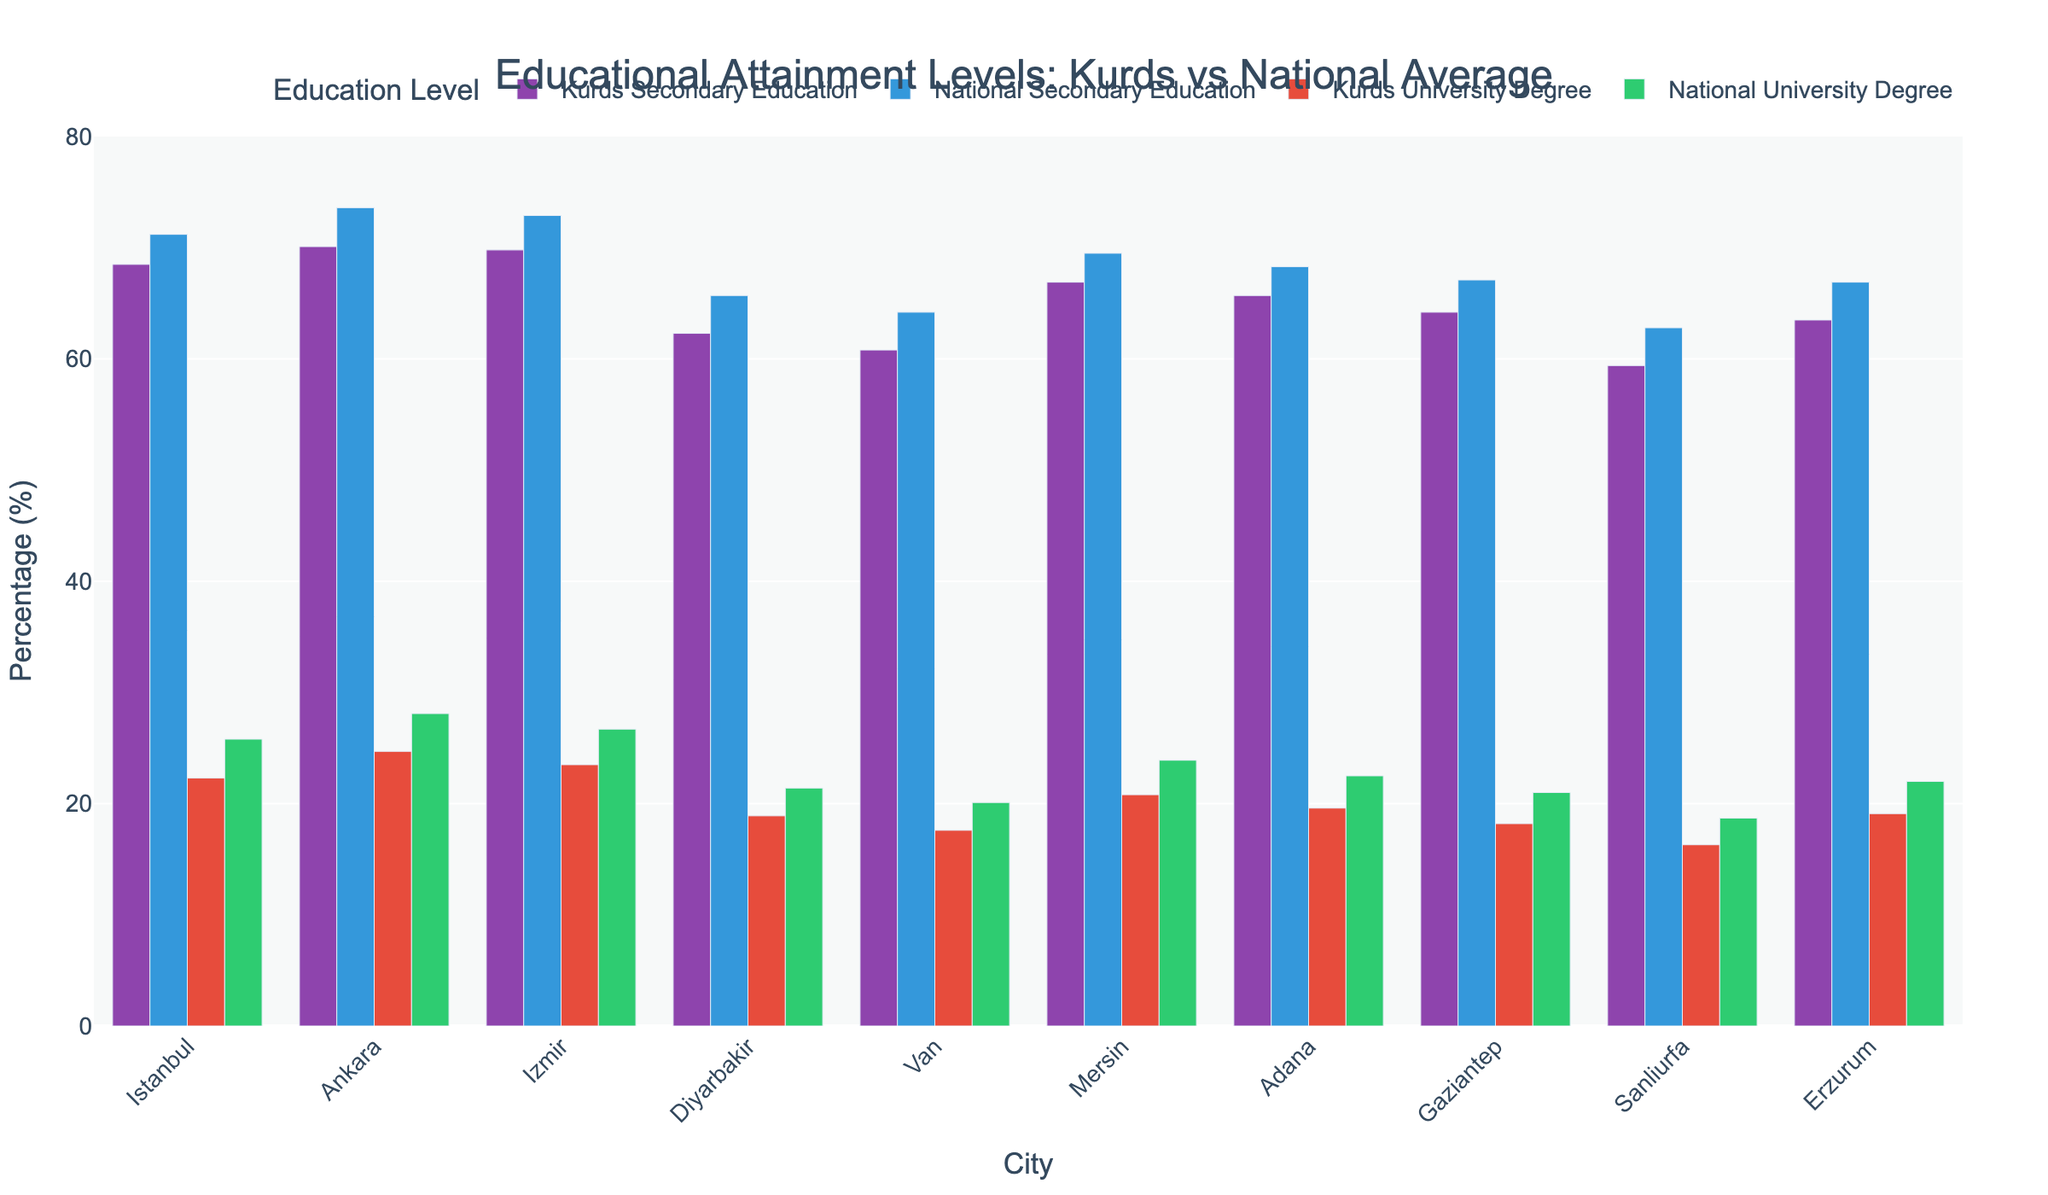What's the difference in secondary education attainment between Kurds in Istanbul and the national average? The chart shows the "Kurds Secondary Education" bar and the "National Secondary Education" bar for Istanbul. The Kurds' percentage is 68.5%, while the national average is 71.2%. The difference is calculated as 71.2% - 68.5% = 2.7%.
Answer: 2.7% Which city shows the smallest gap between Kurds' and national university degree attainment? To determine the smallest gap, compare the differences between the "Kurds University Degree" and "National University Degree" bars for each city. The differences are calculated as follows: Istanbul (3.5%), Ankara (3.4%), Izmir (3.2%), Diyarbakir (2.5%), Van (2.5%), Mersin (3.1%), Adana (2.9%), Gaziantep (2.8%), Sanliurfa (2.4%), Erzurum (2.9%). The smallest gap is in Sanliurfa with a 2.4% difference.
Answer: Sanliurfa Which city has the highest percentage of Kurds with a university degree? Examine the "Kurds University Degree" bars across all cities. The highest value appears in Ankara at 24.7%.
Answer: Ankara What is the average percentage of Kurds with secondary education in the cities provided? Sum the percentages of Kurds with secondary education for all cities and divide by the number of cities: (68.5 + 70.1 + 69.8 + 62.3 + 60.8 + 66.9 + 65.7 + 64.2 + 59.4 + 63.5) / 10 = 65.12%.
Answer: 65.12% Is there a city where both secondary education and university degree attainment for Kurds exceed the national average? Compare the "Kurds Secondary Education" and "National Secondary Education" bars and the "Kurds University Degree" and "National University Degree" bars for each city. None of the cities listed have Kurds' percentages exceeding the national averages in both education levels.
Answer: No What's the total percentage difference in secondary education attainment between Kurds and national averages across all cities? Calculate the differences for each city and sum them: (71.2 - 68.5) + (73.6 - 70.1) + (72.9 - 69.8) + (65.7 - 62.3) + (64.2 - 60.8) + (69.5 - 66.9) + (68.3 - 65.7) + (67.1 - 64.2) + (62.8 - 59.4) + (66.9 - 63.5) = 32.7%.
Answer: 32.7% Which city has the greatest difference in university degree attainment between Kurds and the national average and what is the value? Compare the "Kurds University Degree" and "National University Degree" bars for each city. The greatest difference is in Ankara with a 3.4% difference (28.1% - 24.7%).
Answer: Ankara, 3.4% 